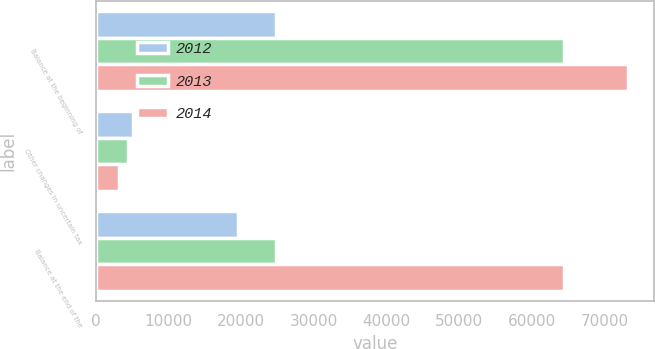<chart> <loc_0><loc_0><loc_500><loc_500><stacked_bar_chart><ecel><fcel>Balance at the beginning of<fcel>Other changes in uncertain tax<fcel>Balance at the end of the<nl><fcel>2012<fcel>24716<fcel>5120<fcel>19596<nl><fcel>2013<fcel>64390<fcel>4395<fcel>24716<nl><fcel>2014<fcel>73199<fcel>3184<fcel>64390<nl></chart> 